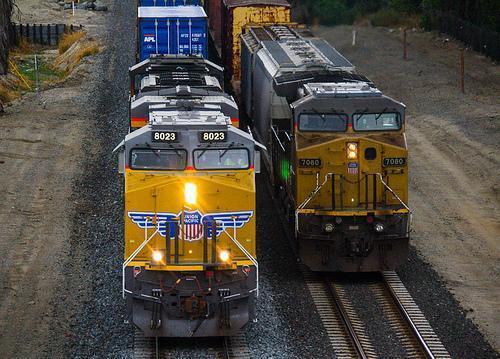How many trains are there?
Give a very brief answer. 2. 